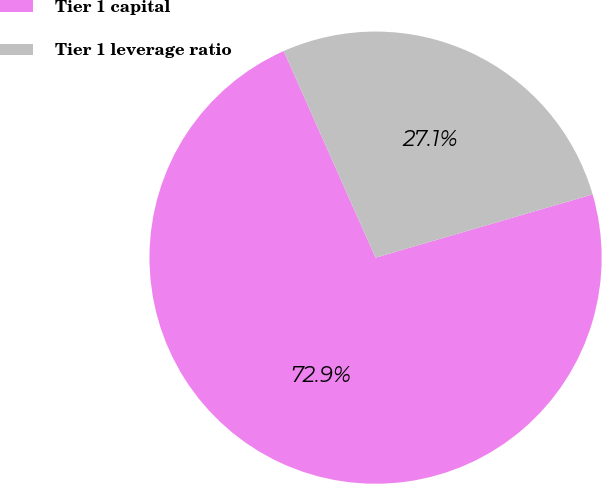Convert chart. <chart><loc_0><loc_0><loc_500><loc_500><pie_chart><fcel>Tier 1 capital<fcel>Tier 1 leverage ratio<nl><fcel>72.86%<fcel>27.14%<nl></chart> 